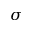Convert formula to latex. <formula><loc_0><loc_0><loc_500><loc_500>\sigma</formula> 